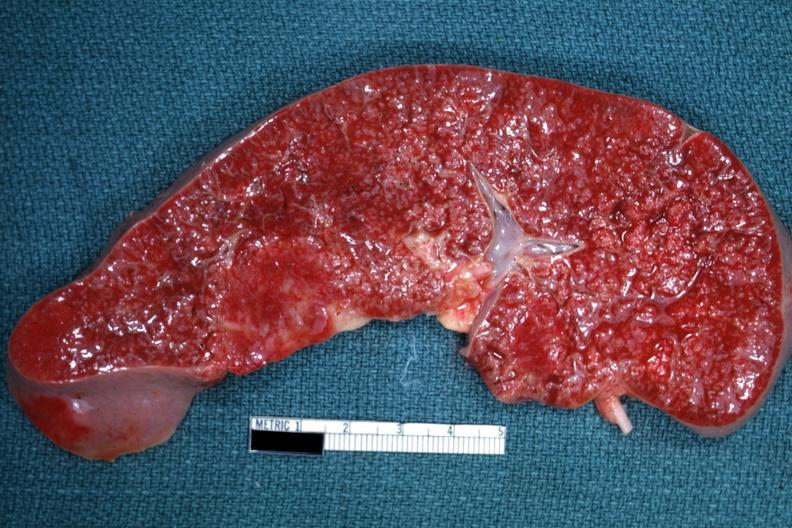does close-up excellent example of interosseous muscle atrophy show cut surface with multiple small infiltrates that simulate granulomata diagnosed as reticulum cell sarcoma?
Answer the question using a single word or phrase. No 